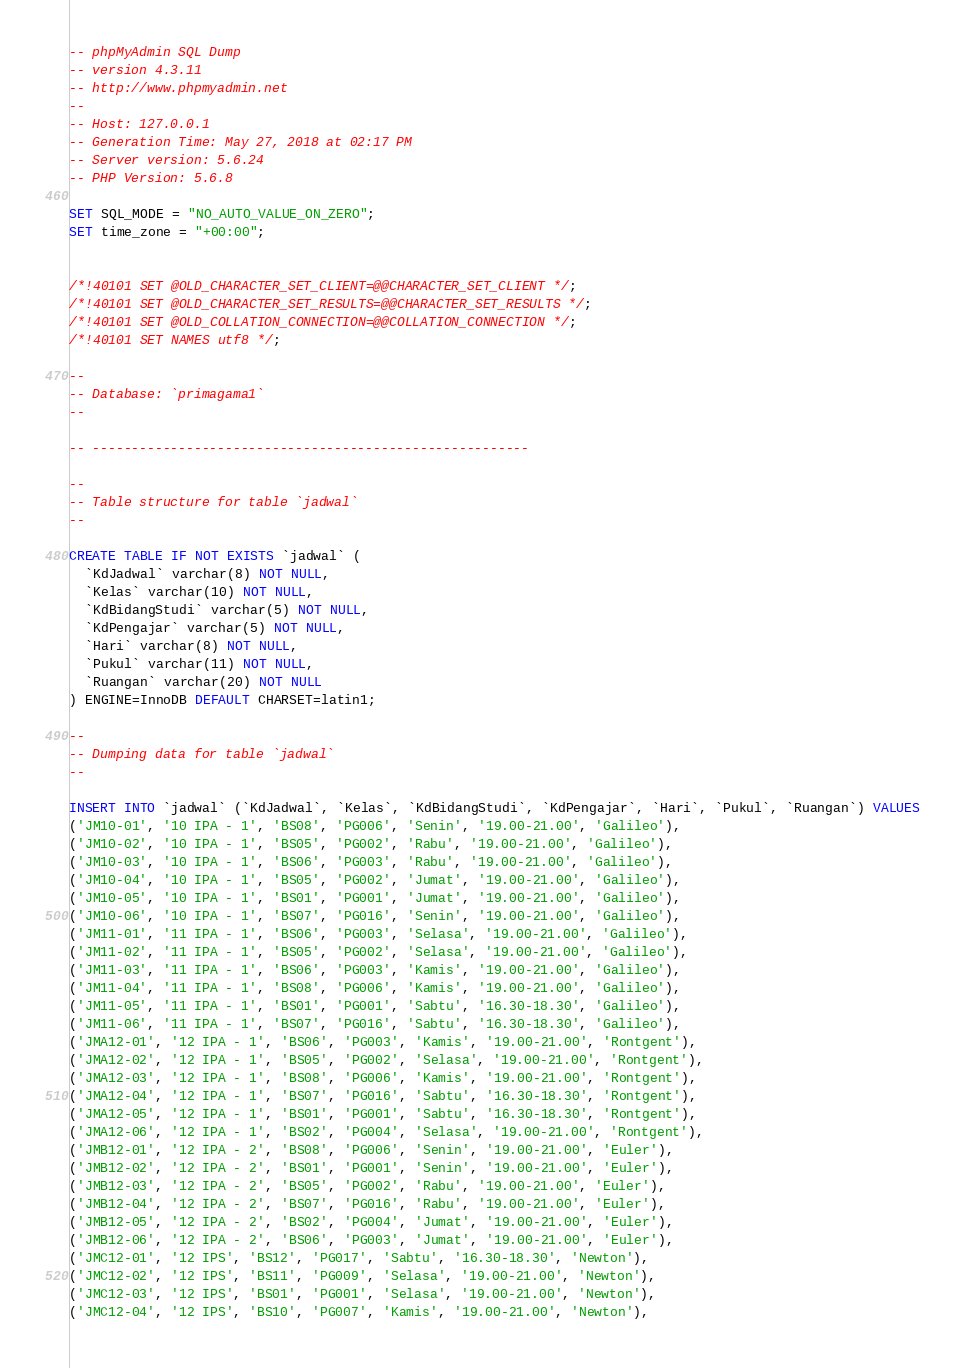<code> <loc_0><loc_0><loc_500><loc_500><_SQL_>-- phpMyAdmin SQL Dump
-- version 4.3.11
-- http://www.phpmyadmin.net
--
-- Host: 127.0.0.1
-- Generation Time: May 27, 2018 at 02:17 PM
-- Server version: 5.6.24
-- PHP Version: 5.6.8

SET SQL_MODE = "NO_AUTO_VALUE_ON_ZERO";
SET time_zone = "+00:00";


/*!40101 SET @OLD_CHARACTER_SET_CLIENT=@@CHARACTER_SET_CLIENT */;
/*!40101 SET @OLD_CHARACTER_SET_RESULTS=@@CHARACTER_SET_RESULTS */;
/*!40101 SET @OLD_COLLATION_CONNECTION=@@COLLATION_CONNECTION */;
/*!40101 SET NAMES utf8 */;

--
-- Database: `primagama1`
--

-- --------------------------------------------------------

--
-- Table structure for table `jadwal`
--

CREATE TABLE IF NOT EXISTS `jadwal` (
  `KdJadwal` varchar(8) NOT NULL,
  `Kelas` varchar(10) NOT NULL,
  `KdBidangStudi` varchar(5) NOT NULL,
  `KdPengajar` varchar(5) NOT NULL,
  `Hari` varchar(8) NOT NULL,
  `Pukul` varchar(11) NOT NULL,
  `Ruangan` varchar(20) NOT NULL
) ENGINE=InnoDB DEFAULT CHARSET=latin1;

--
-- Dumping data for table `jadwal`
--

INSERT INTO `jadwal` (`KdJadwal`, `Kelas`, `KdBidangStudi`, `KdPengajar`, `Hari`, `Pukul`, `Ruangan`) VALUES
('JM10-01', '10 IPA - 1', 'BS08', 'PG006', 'Senin', '19.00-21.00', 'Galileo'),
('JM10-02', '10 IPA - 1', 'BS05', 'PG002', 'Rabu', '19.00-21.00', 'Galileo'),
('JM10-03', '10 IPA - 1', 'BS06', 'PG003', 'Rabu', '19.00-21.00', 'Galileo'),
('JM10-04', '10 IPA - 1', 'BS05', 'PG002', 'Jumat', '19.00-21.00', 'Galileo'),
('JM10-05', '10 IPA - 1', 'BS01', 'PG001', 'Jumat', '19.00-21.00', 'Galileo'),
('JM10-06', '10 IPA - 1', 'BS07', 'PG016', 'Senin', '19.00-21.00', 'Galileo'),
('JM11-01', '11 IPA - 1', 'BS06', 'PG003', 'Selasa', '19.00-21.00', 'Galileo'),
('JM11-02', '11 IPA - 1', 'BS05', 'PG002', 'Selasa', '19.00-21.00', 'Galileo'),
('JM11-03', '11 IPA - 1', 'BS06', 'PG003', 'Kamis', '19.00-21.00', 'Galileo'),
('JM11-04', '11 IPA - 1', 'BS08', 'PG006', 'Kamis', '19.00-21.00', 'Galileo'),
('JM11-05', '11 IPA - 1', 'BS01', 'PG001', 'Sabtu', '16.30-18.30', 'Galileo'),
('JM11-06', '11 IPA - 1', 'BS07', 'PG016', 'Sabtu', '16.30-18.30', 'Galileo'),
('JMA12-01', '12 IPA - 1', 'BS06', 'PG003', 'Kamis', '19.00-21.00', 'Rontgent'),
('JMA12-02', '12 IPA - 1', 'BS05', 'PG002', 'Selasa', '19.00-21.00', 'Rontgent'),
('JMA12-03', '12 IPA - 1', 'BS08', 'PG006', 'Kamis', '19.00-21.00', 'Rontgent'),
('JMA12-04', '12 IPA - 1', 'BS07', 'PG016', 'Sabtu', '16.30-18.30', 'Rontgent'),
('JMA12-05', '12 IPA - 1', 'BS01', 'PG001', 'Sabtu', '16.30-18.30', 'Rontgent'),
('JMA12-06', '12 IPA - 1', 'BS02', 'PG004', 'Selasa', '19.00-21.00', 'Rontgent'),
('JMB12-01', '12 IPA - 2', 'BS08', 'PG006', 'Senin', '19.00-21.00', 'Euler'),
('JMB12-02', '12 IPA - 2', 'BS01', 'PG001', 'Senin', '19.00-21.00', 'Euler'),
('JMB12-03', '12 IPA - 2', 'BS05', 'PG002', 'Rabu', '19.00-21.00', 'Euler'),
('JMB12-04', '12 IPA - 2', 'BS07', 'PG016', 'Rabu', '19.00-21.00', 'Euler'),
('JMB12-05', '12 IPA - 2', 'BS02', 'PG004', 'Jumat', '19.00-21.00', 'Euler'),
('JMB12-06', '12 IPA - 2', 'BS06', 'PG003', 'Jumat', '19.00-21.00', 'Euler'),
('JMC12-01', '12 IPS', 'BS12', 'PG017', 'Sabtu', '16.30-18.30', 'Newton'),
('JMC12-02', '12 IPS', 'BS11', 'PG009', 'Selasa', '19.00-21.00', 'Newton'),
('JMC12-03', '12 IPS', 'BS01', 'PG001', 'Selasa', '19.00-21.00', 'Newton'),
('JMC12-04', '12 IPS', 'BS10', 'PG007', 'Kamis', '19.00-21.00', 'Newton'),</code> 